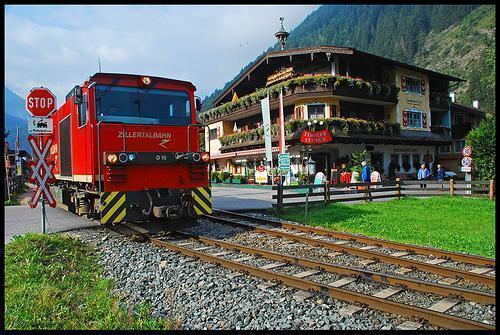What zone is this area?
Indicate the correct choice and explain in the format: 'Answer: answer
Rationale: rationale.'
Options: Tourist, residential, shopping, business. Answer: tourist.
Rationale: Visitors are this place's main customers 